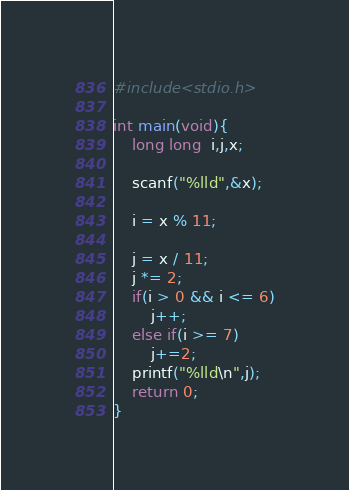Convert code to text. <code><loc_0><loc_0><loc_500><loc_500><_C_>#include<stdio.h>

int main(void){
    long long  i,j,x;

    scanf("%lld",&x);

    i = x % 11;

    j = x / 11;
    j *= 2;
    if(i > 0 && i <= 6)
        j++;
    else if(i >= 7)
        j+=2;
    printf("%lld\n",j);
    return 0;
}</code> 